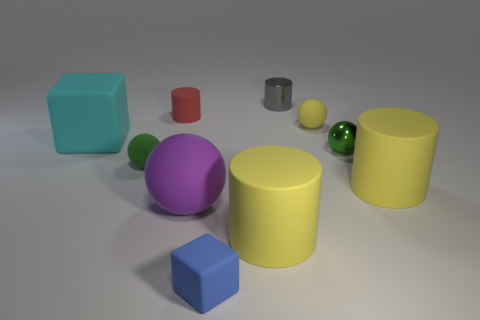Is the number of tiny cylinders in front of the big cyan block less than the number of green metal balls behind the purple matte object?
Offer a very short reply. Yes. What shape is the yellow matte object behind the cyan rubber block left of the tiny green ball on the left side of the tiny gray thing?
Your answer should be very brief. Sphere. The matte object that is behind the metal sphere and left of the red object has what shape?
Offer a very short reply. Cube. Is there a tiny brown ball that has the same material as the large purple object?
Ensure brevity in your answer.  No. The matte object that is the same color as the metallic ball is what size?
Offer a very short reply. Small. What color is the cylinder right of the tiny yellow sphere?
Provide a succinct answer. Yellow. Is the shape of the purple matte object the same as the metal object behind the cyan matte thing?
Offer a very short reply. No. Is there a big metallic object of the same color as the small shiny cylinder?
Provide a short and direct response. No. The purple sphere that is made of the same material as the large cyan block is what size?
Provide a short and direct response. Large. There is a tiny blue thing that is in front of the gray thing; is its shape the same as the cyan rubber object?
Ensure brevity in your answer.  Yes. 